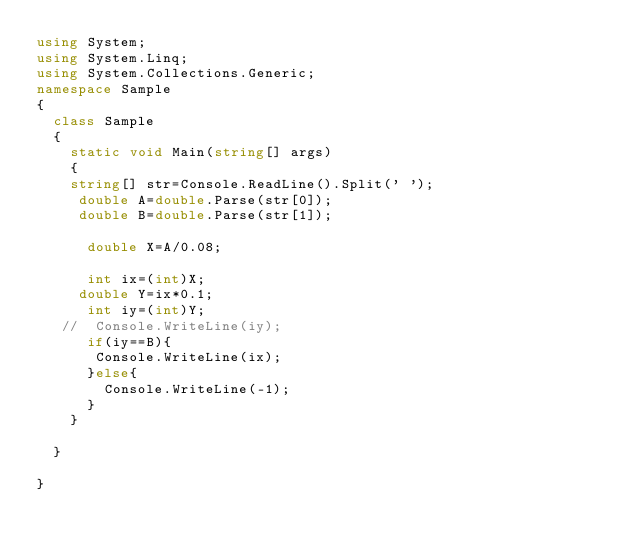<code> <loc_0><loc_0><loc_500><loc_500><_C#_>using System;
using System.Linq;
using System.Collections.Generic;
namespace Sample
{
  class Sample
  {
    static void Main(string[] args)
    {
    string[] str=Console.ReadLine().Split(' ');
     double A=double.Parse(str[0]);
     double B=double.Parse(str[1]);
      
      double X=A/0.08;
      
      int ix=(int)X;
     double Y=ix*0.1;
      int iy=(int)Y;
   //  Console.WriteLine(iy);
      if(iy==B){
       Console.WriteLine(ix); 
      }else{
        Console.WriteLine(-1);
      }
    }
    
  }

}
</code> 